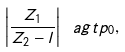<formula> <loc_0><loc_0><loc_500><loc_500>\left | \frac { Z _ { 1 } } { Z _ { 2 } - l } \right | \ a g t p _ { 0 } ,</formula> 